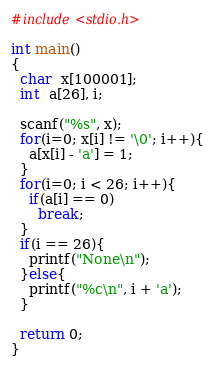Convert code to text. <code><loc_0><loc_0><loc_500><loc_500><_C_>#include<stdio.h>

int main()
{
  char  x[100001];
  int  a[26], i;
  
  scanf("%s", x);
  for(i=0; x[i] != '\0'; i++){
    a[x[i] - 'a'] = 1;
  }
  for(i=0; i < 26; i++){
    if(a[i] == 0)
      break;
  }
  if(i == 26){
    printf("None\n");
  }else{
    printf("%c\n", i + 'a');
  }
  
  return 0;
}</code> 